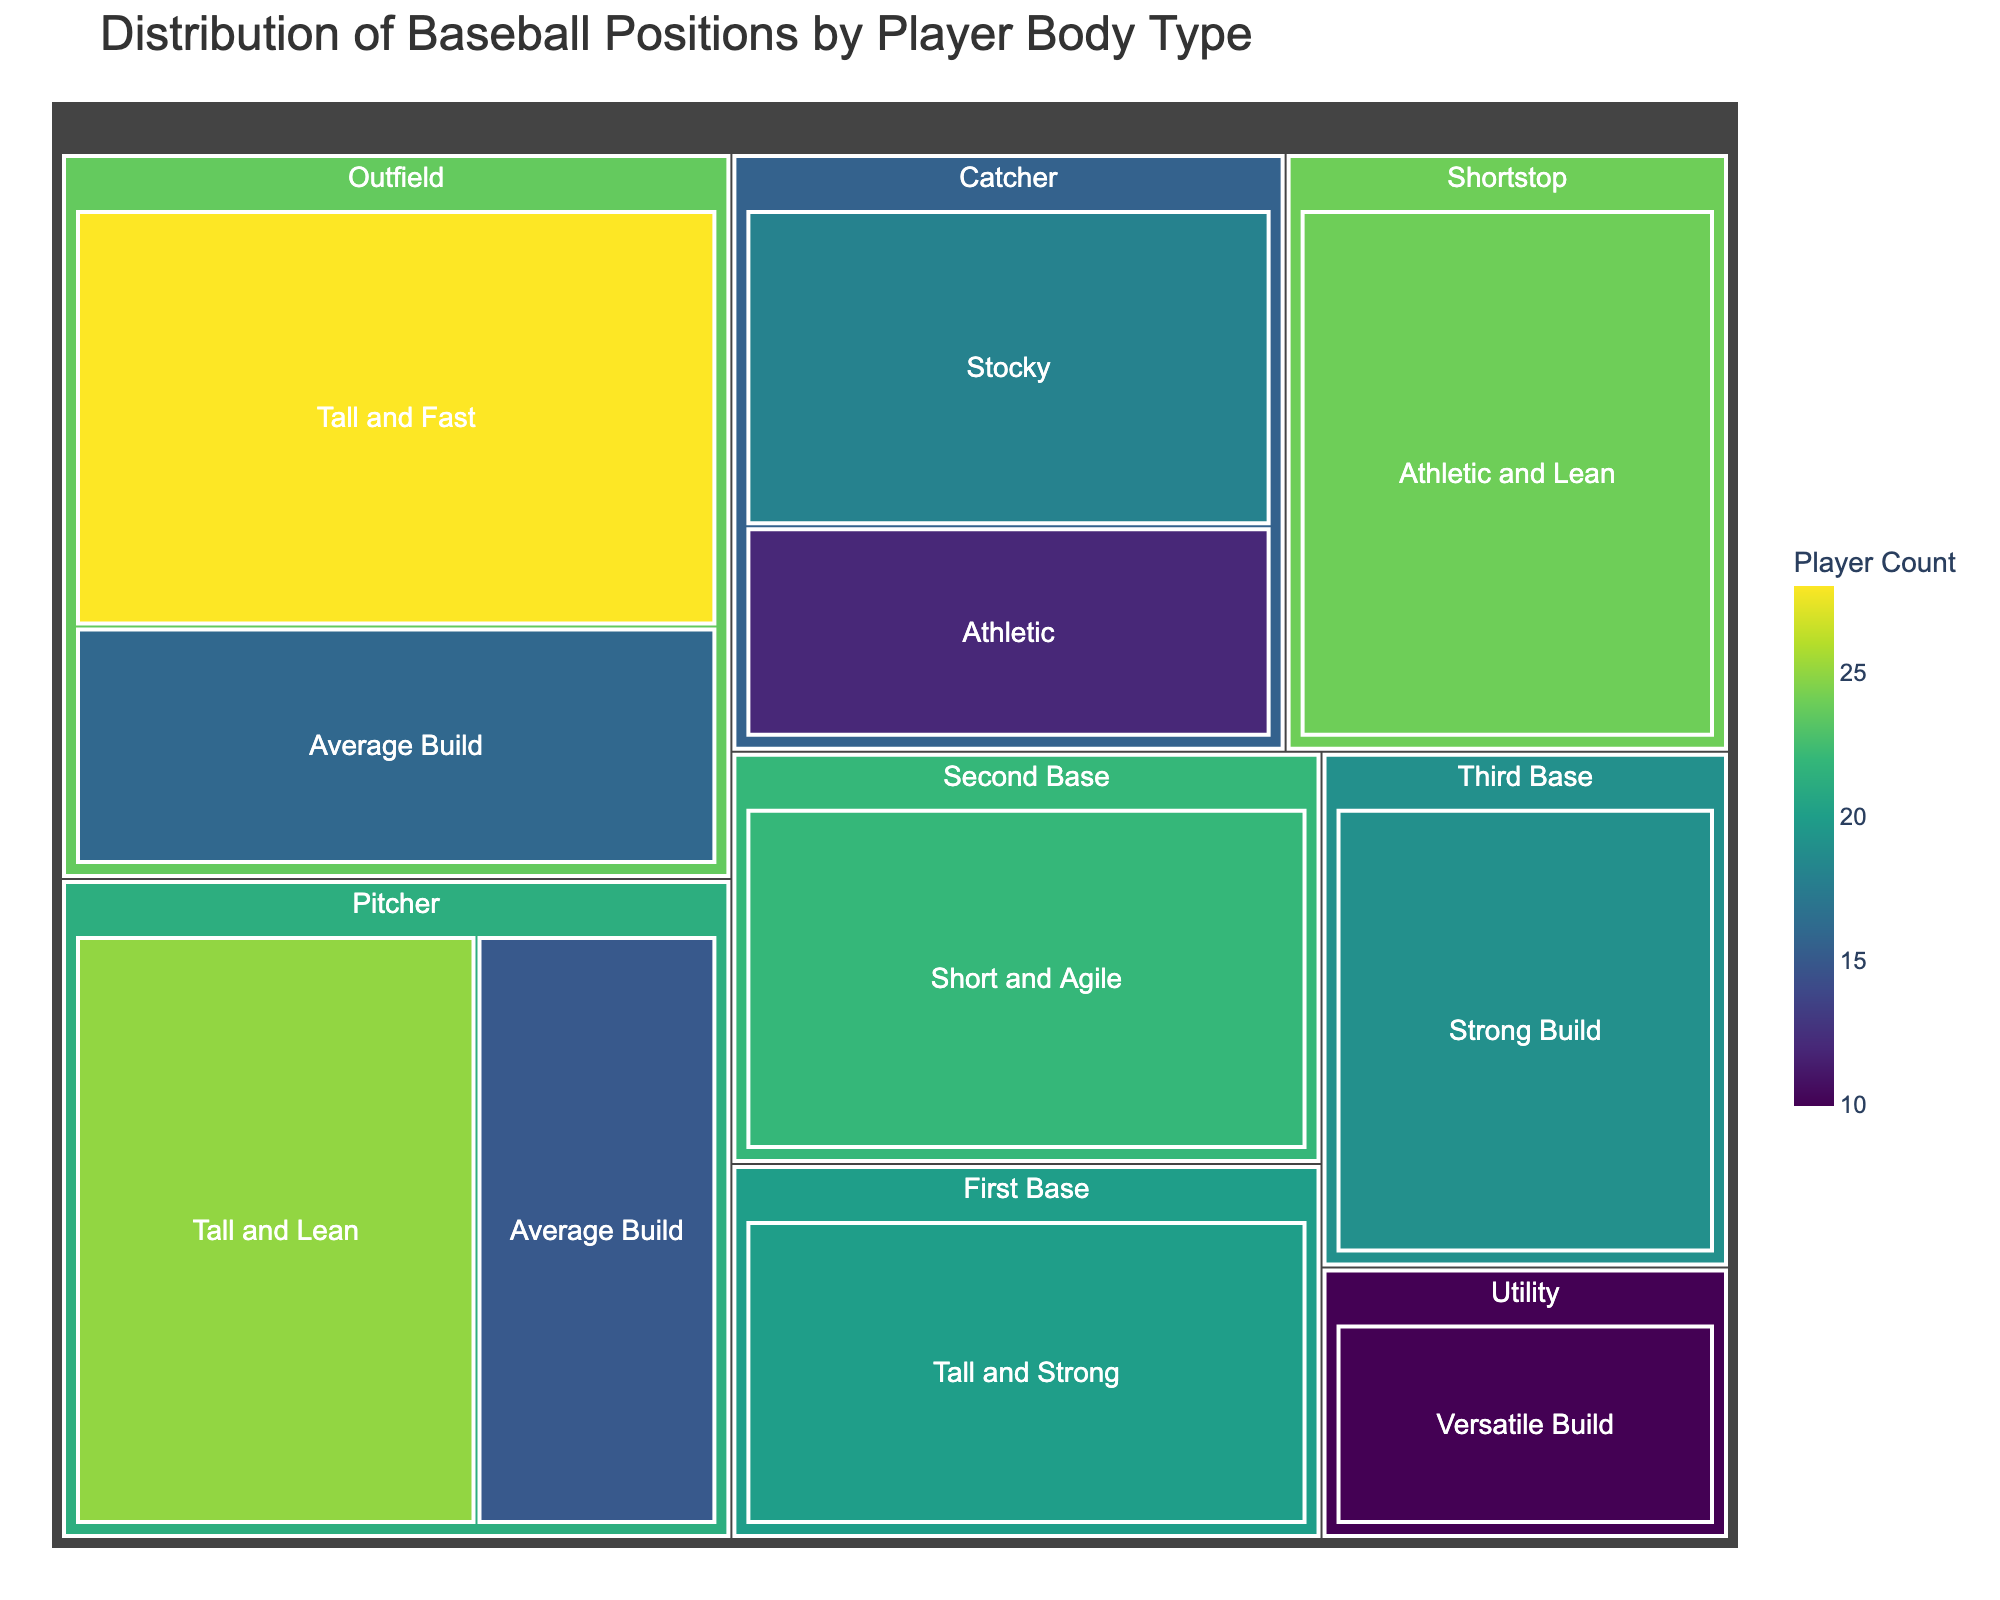What is the title of the treemap? The title is located at the top of the figure and provides an overview of what the treemap represents.
Answer: Distribution of Baseball Positions by Player Body Type Which body type has the highest count for Outfield position? By looking at the size of the tiles under the Outfield position, the one with the highest count will have the largest area.
Answer: Tall and Fast What is the total count of players in the Pitcher position? To find the total, add the counts of 'Tall and Lean' and 'Average Build' under the Pitcher position: 25 (Tall and Lean) + 15 (Average Build).
Answer: 40 Which position has the most varied body types? By observing the number of different body types (tiles) associated with each position, the position with the highest variety will have the most tiles.
Answer: Outfield What is the combined count for 'Athletic' body types across all positions? Identify and add all tiles labeled 'Athletic': 12 (Catcher) + 24 (Shortstop).
Answer: 36 How does the count of 'Tall and Lean' players compare to 'Tall and Fast' players? Compare the counts by looking at the numbers associated with 'Tall and Lean' (25) and 'Tall and Fast' (28).
Answer: 'Tall and Fast' has more players Which body type is least represented in the data? The least represented body type would have the smallest tile area and the smallest count number.
Answer: Versatile Build Are there more 'Tall and Strong' players or 'Tall and Lean' players? Compare the counts of 'Tall and Strong' (20) and 'Tall and Lean' (25) by looking at the respective tiles.
Answer: Tall and Lean What is the ratio of players in the Utility position to those in the Catcher position? Divide the count of Utility players by the total count of Catcher players: 10 (Utility) / (18 + 12) (Catcher).
Answer: 10/30 or 1/3 Which position has the highest total count of players, and what is this count? Sum the counts for each position and identify the one with the highest total. Outfield has the highest: 28 (Tall and Fast) + 16 (Average Build).
Answer: 44 